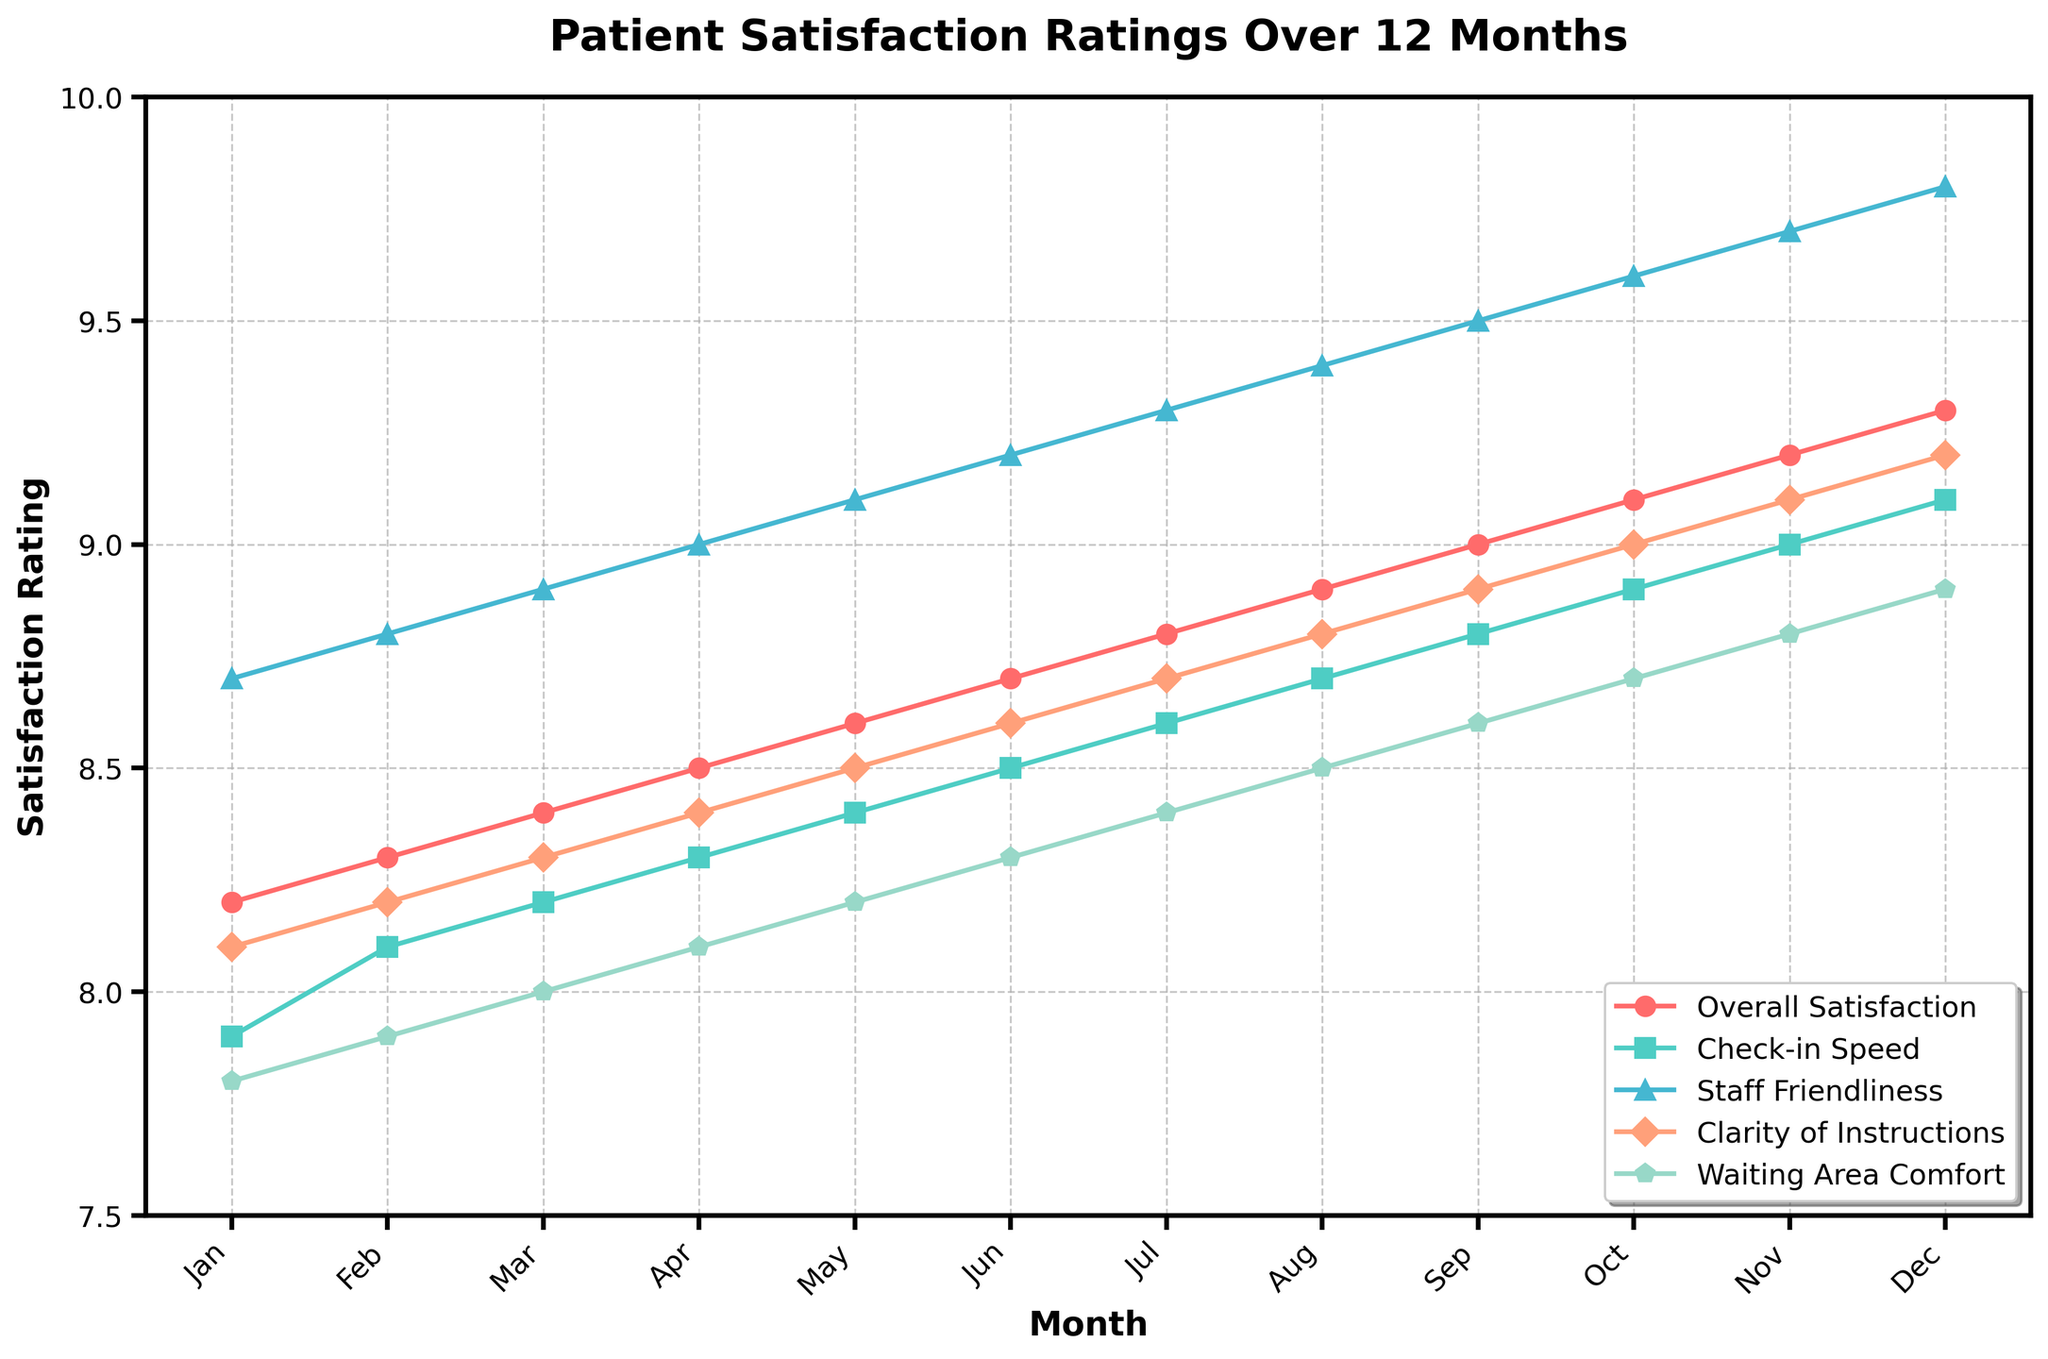What is the overall trend for 'Staff Friendliness' over the 12 months? First, observe how the 'Staff Friendliness' line evolves month to month. Notice that it increases steadily from January to December. Therefore, the trend is upward.
Answer: Upward During which month did 'Overall Satisfaction' surpass 9 for the first time? Look at the 'Overall Satisfaction' line and check the values for each month. The rating first exceeds 9 in September.
Answer: September In which month is the difference between 'Check-in Speed' and 'Waiting Area Comfort' the largest? For each month, calculate the difference between 'Check-in Speed' and 'Waiting Area Comfort'. The largest difference, 0.4, occurs in January.
Answer: January Compare the ratings for 'Clarity of Instructions' and 'Waiting Area Comfort' in October. Which one is higher? Observe the values in October for both categories. 'Clarity of Instructions' is 9.0 and 'Waiting Area Comfort' is 8.7. 'Clarity of Instructions' is higher.
Answer: Clarity of Instructions What's the average rating for 'Overall Satisfaction' throughout the year? Add all 'Overall Satisfaction' ratings and divide by 12: (8.2 + 8.3 + 8.4 + 8.5 + 8.6 + 8.7 + 8.8 + 8.9 + 9.0 + 9.1 + 9.2 + 9.3) / 12 = 8.725
Answer: 8.725 Which category improves the most from January to December? Calculate the difference between the December and January values for each category: 'Overall Satisfaction' (9.3 - 8.2 = 1.1), 'Check-in Speed' (9.1 - 7.9 = 1.2), 'Staff Friendliness' (9.8 - 8.7 = 1.1), 'Clarity of Instructions' (9.2 - 8.1 = 1.1), 'Waiting Area Comfort' (8.9 - 7.8 = 1.1). The highest improvement is in 'Check-in Speed' which is 1.2.
Answer: Check-in Speed What is the median rating for 'Waiting Area Comfort' over the year? Sort the 'Waiting Area Comfort' ratings and find the middle values since there are 12 months: (7.8, 7.9, 8.0, 8.1, 8.2, 8.3, 8.4, 8.5, 8.6, 8.7, 8.8, 8.9). The median is the average of the 6th and 7th values: (8.3 + 8.4) / 2 = 8.35
Answer: 8.35 Does 'Check-in Speed' rating ever drop throughout the 12 months? Examine the 'Check-in Speed' line and check month-to-month. The rating consistently increases without dropping.
Answer: No 